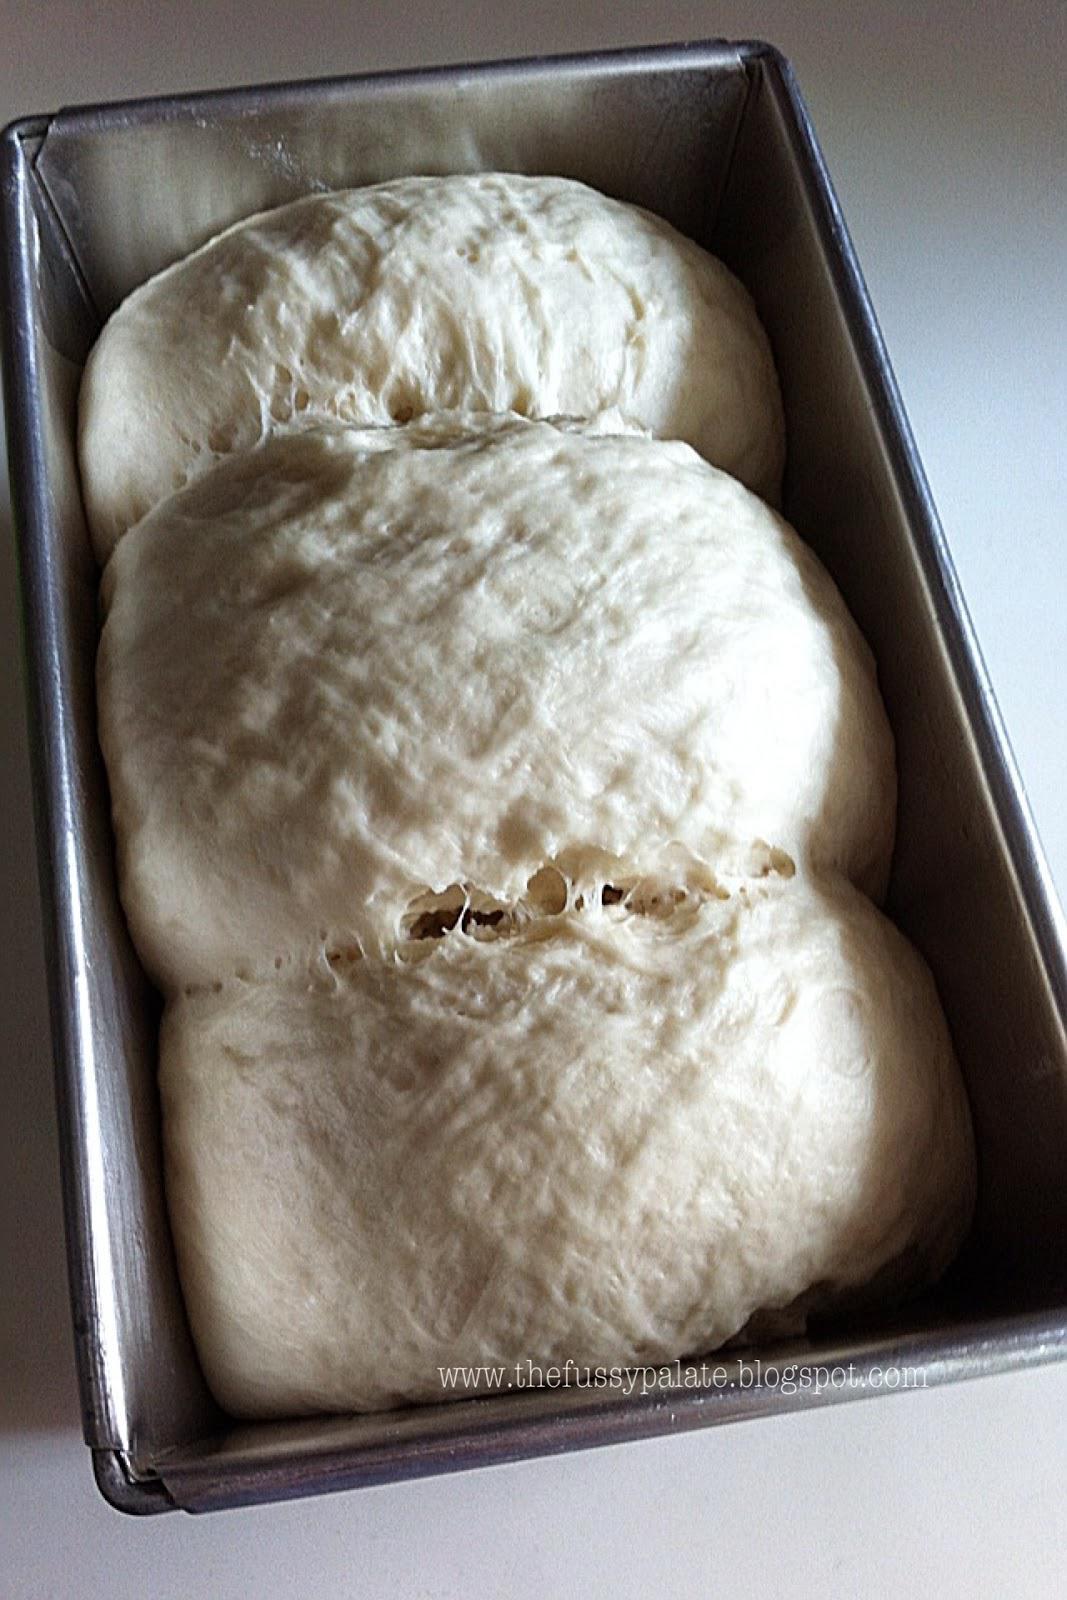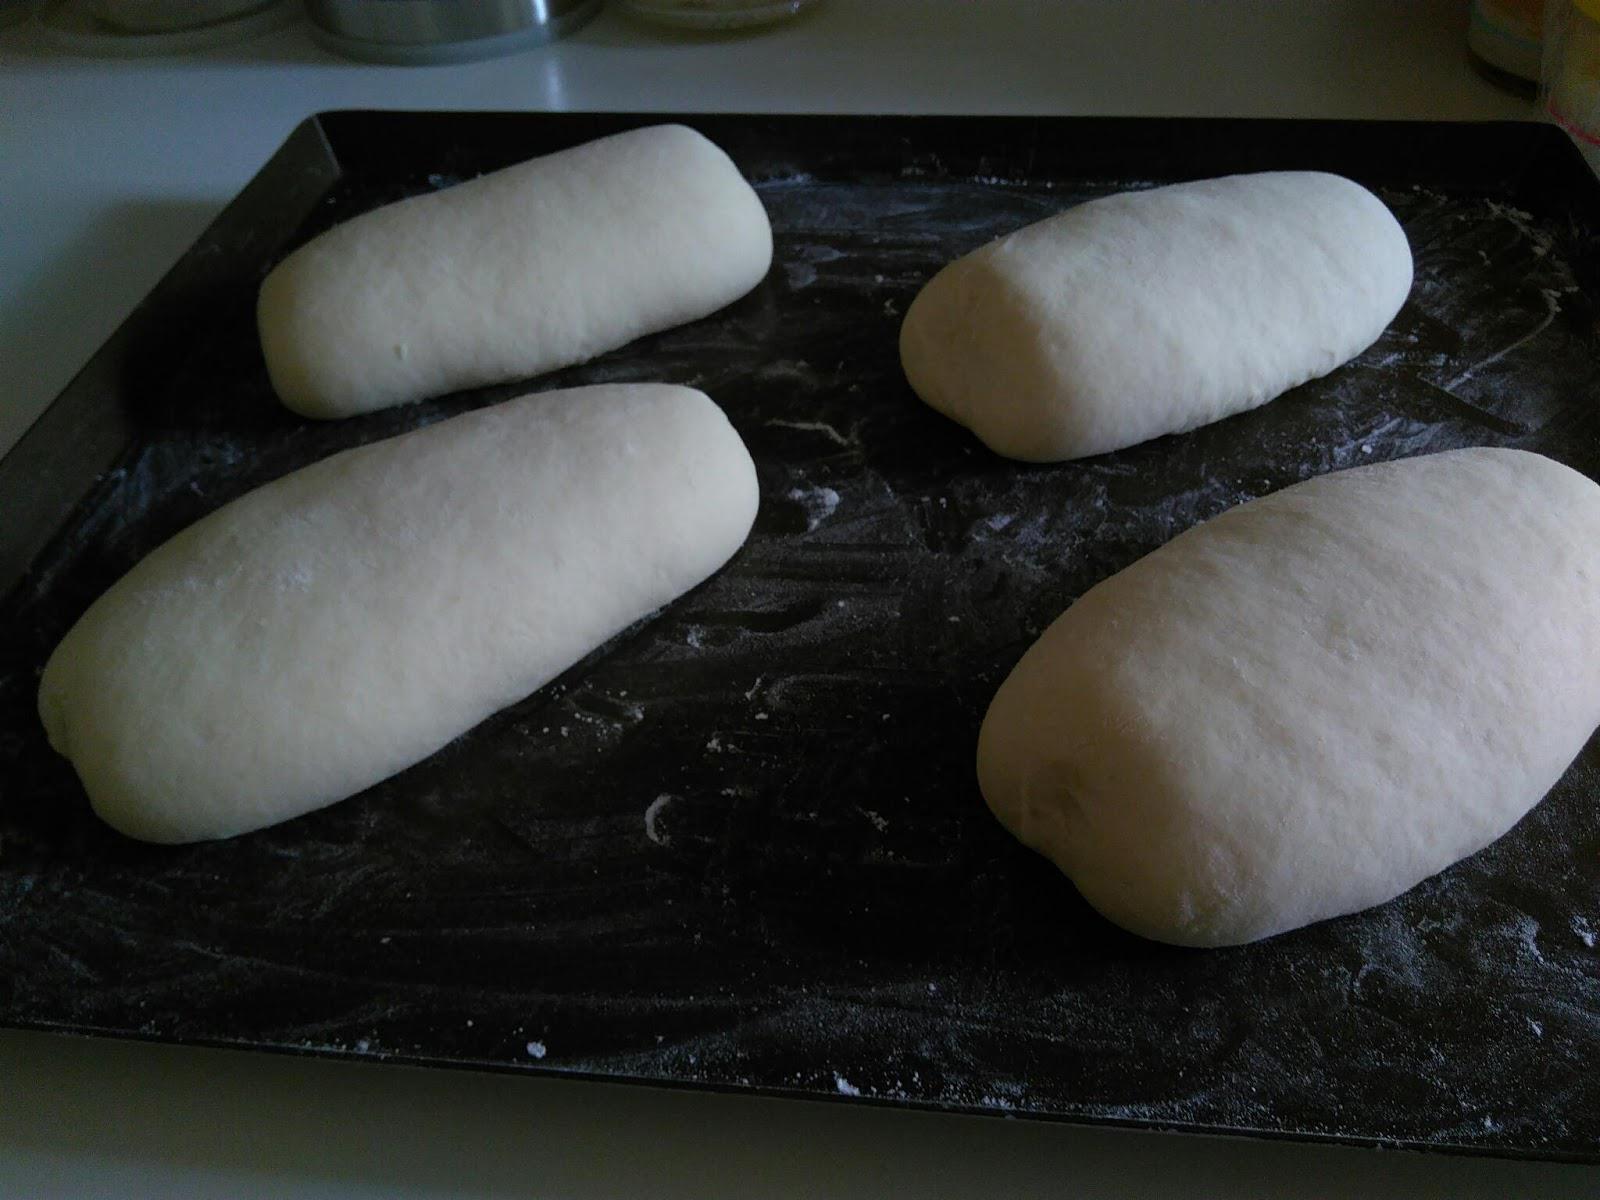The first image is the image on the left, the second image is the image on the right. Given the left and right images, does the statement "Some of the dough is still in the mixing bowl." hold true? Answer yes or no. No. 